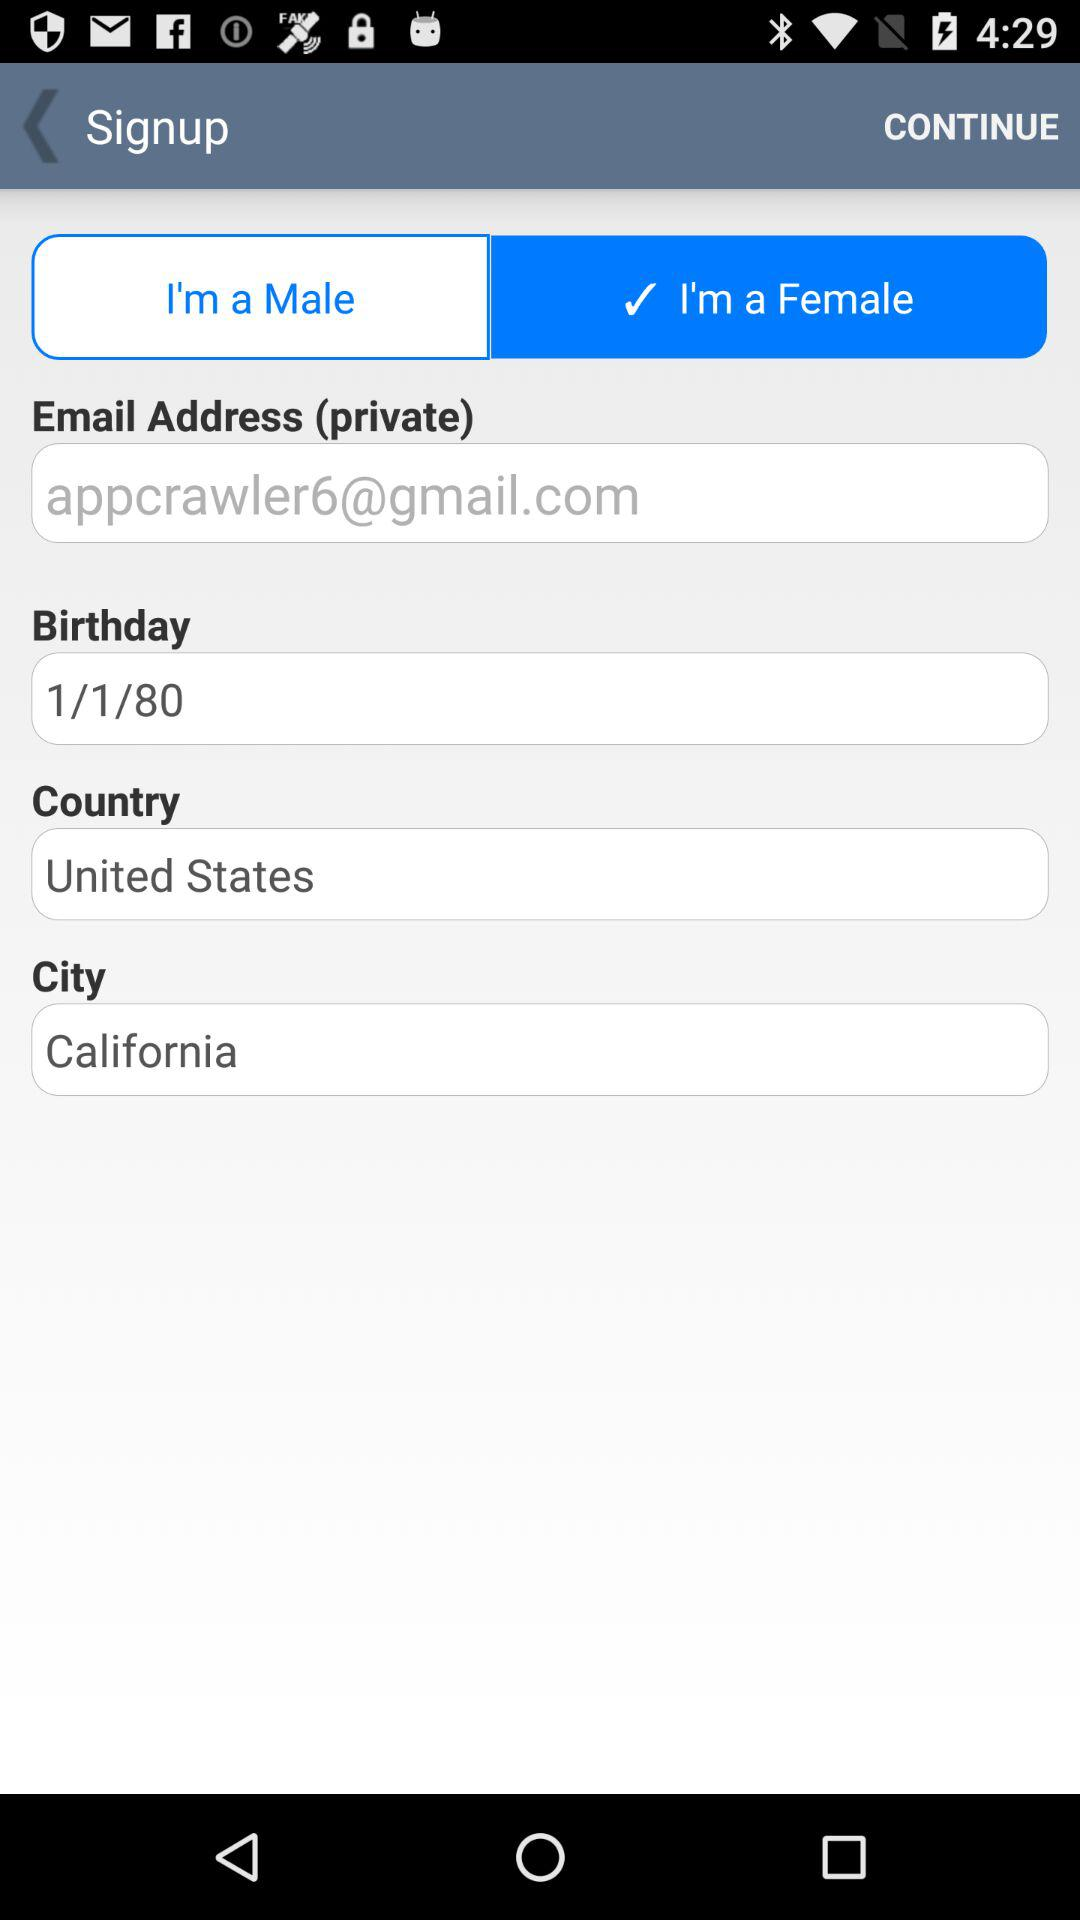What is the name of the city? The name of the city is California. 